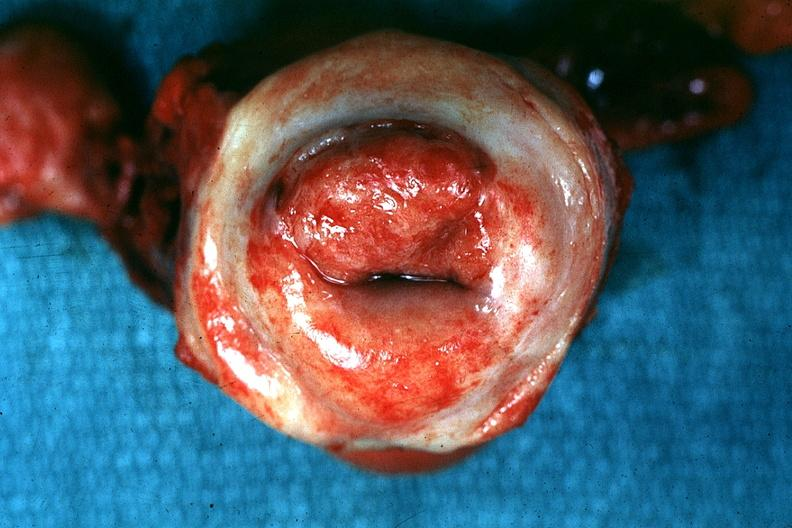does this image show excellent example tumor labeled as invasive?
Answer the question using a single word or phrase. Yes 